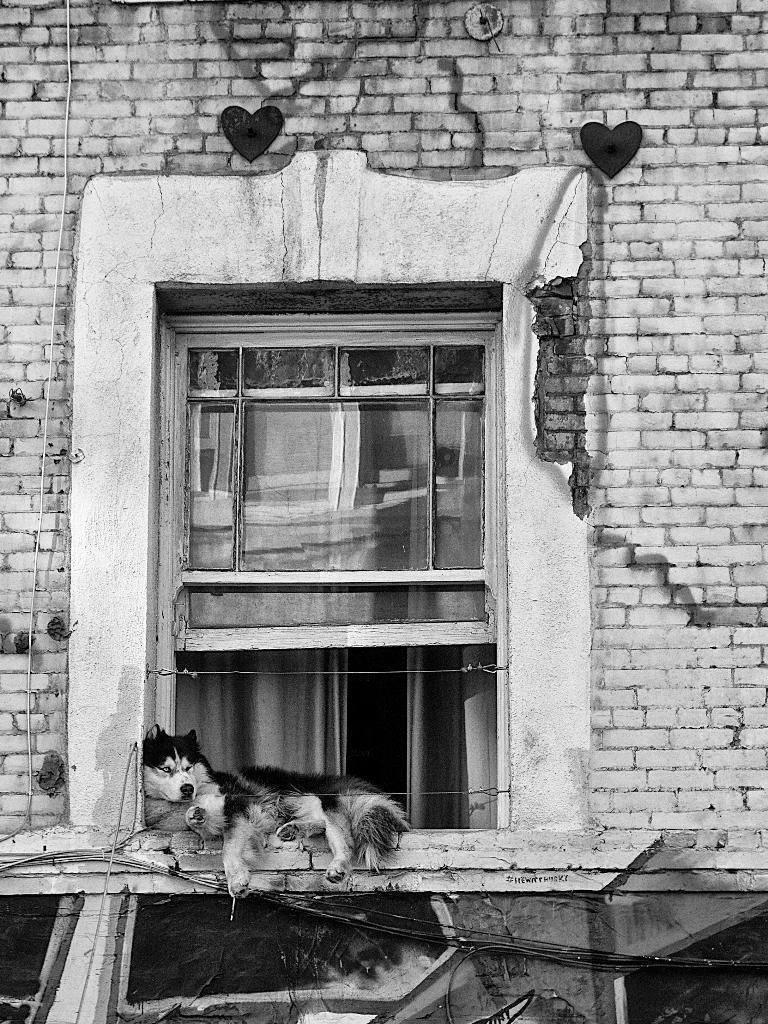In one or two sentences, can you explain what this image depicts? This is the black and white image and we can see a building with a window and there is a dog lying on the wall. 